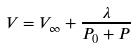<formula> <loc_0><loc_0><loc_500><loc_500>V = V _ { \infty } + \frac { \lambda } { P _ { 0 } + P }</formula> 